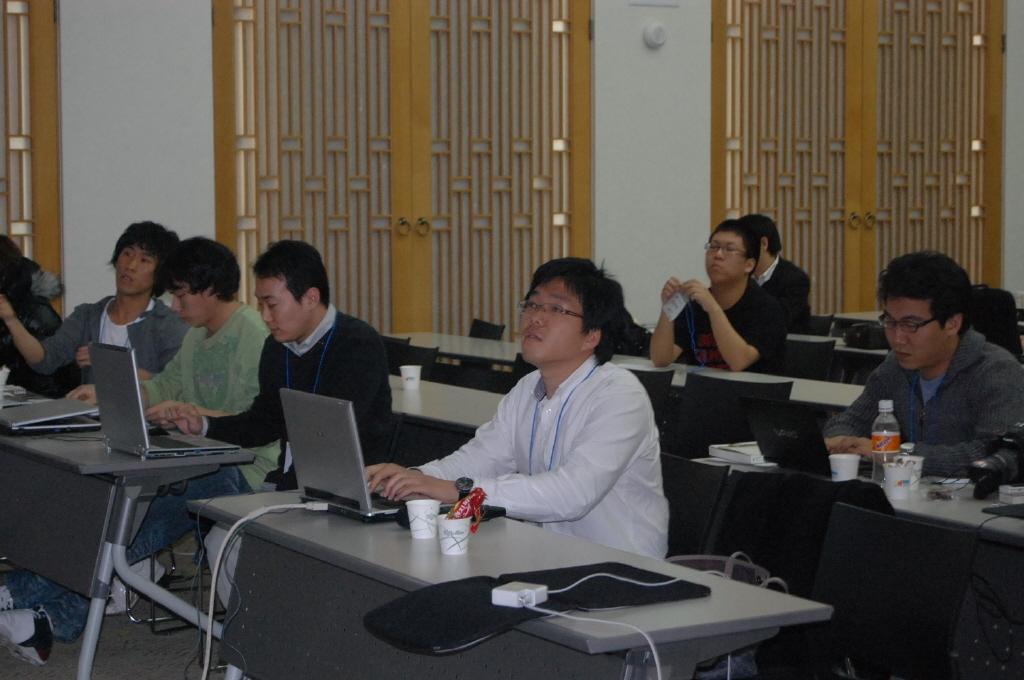Could you give a brief overview of what you see in this image? Here we can see few persons are sitting on the chairs. There are tables. Here we can see laptops, cups, bottle, and cables. This is floor. In the background we can see a wall and a door. 